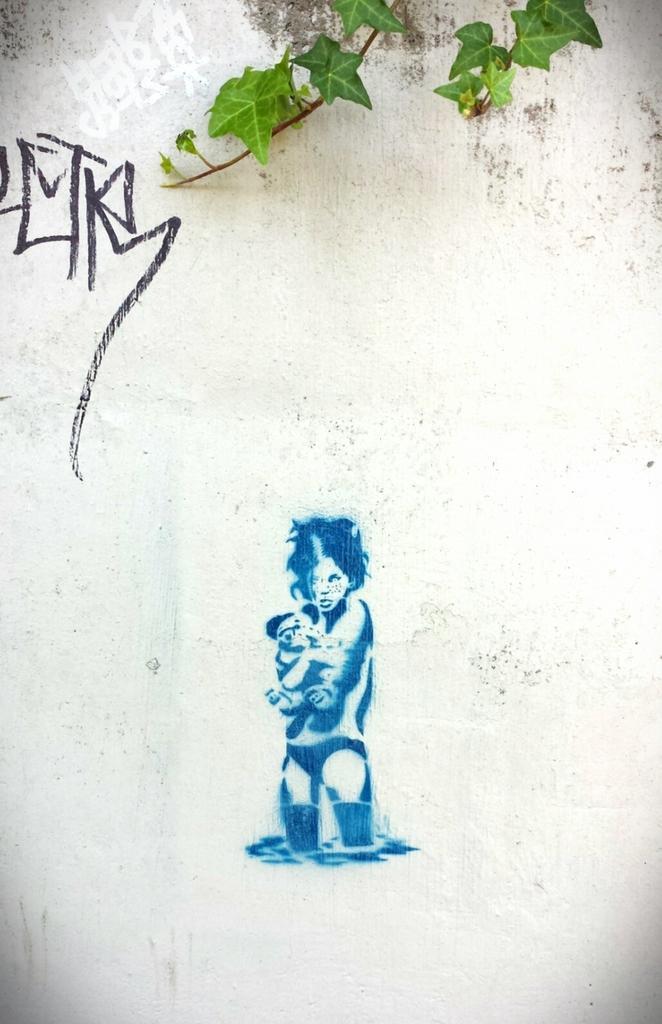In one or two sentences, can you explain what this image depicts? As we can see in the image there is a white color wall and leaves. On wall there is painting. 